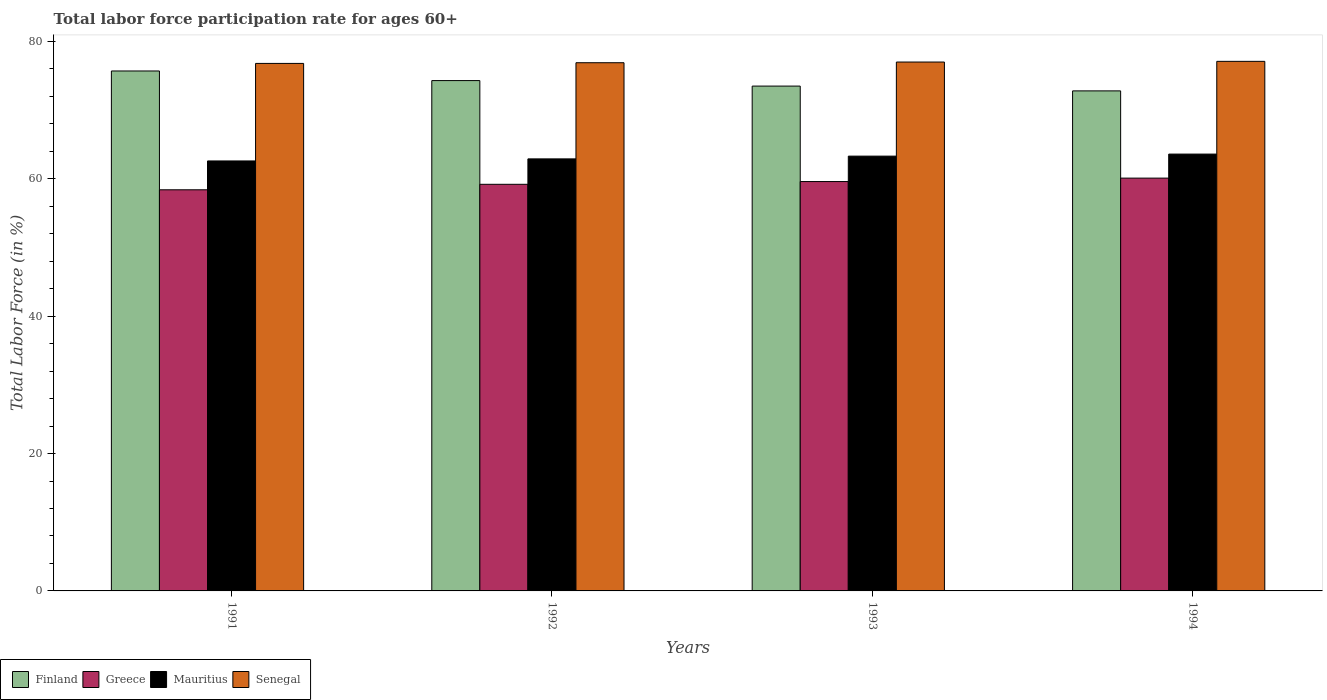How many groups of bars are there?
Give a very brief answer. 4. Are the number of bars per tick equal to the number of legend labels?
Your response must be concise. Yes. Are the number of bars on each tick of the X-axis equal?
Your answer should be compact. Yes. In how many cases, is the number of bars for a given year not equal to the number of legend labels?
Your answer should be compact. 0. What is the labor force participation rate in Greece in 1991?
Make the answer very short. 58.4. Across all years, what is the maximum labor force participation rate in Senegal?
Provide a succinct answer. 77.1. Across all years, what is the minimum labor force participation rate in Greece?
Provide a succinct answer. 58.4. In which year was the labor force participation rate in Greece maximum?
Make the answer very short. 1994. In which year was the labor force participation rate in Senegal minimum?
Your response must be concise. 1991. What is the total labor force participation rate in Finland in the graph?
Your answer should be compact. 296.3. What is the difference between the labor force participation rate in Finland in 1991 and that in 1994?
Offer a terse response. 2.9. What is the difference between the labor force participation rate in Finland in 1992 and the labor force participation rate in Mauritius in 1994?
Provide a succinct answer. 10.7. What is the average labor force participation rate in Mauritius per year?
Offer a very short reply. 63.1. In the year 1994, what is the difference between the labor force participation rate in Greece and labor force participation rate in Mauritius?
Ensure brevity in your answer.  -3.5. In how many years, is the labor force participation rate in Senegal greater than 12 %?
Provide a short and direct response. 4. What is the ratio of the labor force participation rate in Greece in 1991 to that in 1994?
Ensure brevity in your answer.  0.97. What is the difference between the highest and the lowest labor force participation rate in Greece?
Your answer should be very brief. 1.7. Is the sum of the labor force participation rate in Mauritius in 1992 and 1994 greater than the maximum labor force participation rate in Greece across all years?
Your answer should be compact. Yes. What does the 2nd bar from the left in 1991 represents?
Provide a short and direct response. Greece. What does the 2nd bar from the right in 1993 represents?
Give a very brief answer. Mauritius. How many bars are there?
Provide a succinct answer. 16. Are all the bars in the graph horizontal?
Ensure brevity in your answer.  No. What is the difference between two consecutive major ticks on the Y-axis?
Your answer should be compact. 20. Where does the legend appear in the graph?
Your answer should be very brief. Bottom left. How many legend labels are there?
Offer a terse response. 4. How are the legend labels stacked?
Ensure brevity in your answer.  Horizontal. What is the title of the graph?
Offer a very short reply. Total labor force participation rate for ages 60+. Does "Micronesia" appear as one of the legend labels in the graph?
Your answer should be compact. No. What is the Total Labor Force (in %) of Finland in 1991?
Offer a very short reply. 75.7. What is the Total Labor Force (in %) of Greece in 1991?
Your answer should be compact. 58.4. What is the Total Labor Force (in %) in Mauritius in 1991?
Offer a terse response. 62.6. What is the Total Labor Force (in %) of Senegal in 1991?
Keep it short and to the point. 76.8. What is the Total Labor Force (in %) in Finland in 1992?
Provide a succinct answer. 74.3. What is the Total Labor Force (in %) in Greece in 1992?
Ensure brevity in your answer.  59.2. What is the Total Labor Force (in %) in Mauritius in 1992?
Offer a very short reply. 62.9. What is the Total Labor Force (in %) of Senegal in 1992?
Offer a terse response. 76.9. What is the Total Labor Force (in %) in Finland in 1993?
Ensure brevity in your answer.  73.5. What is the Total Labor Force (in %) of Greece in 1993?
Provide a short and direct response. 59.6. What is the Total Labor Force (in %) in Mauritius in 1993?
Offer a terse response. 63.3. What is the Total Labor Force (in %) of Senegal in 1993?
Provide a succinct answer. 77. What is the Total Labor Force (in %) in Finland in 1994?
Offer a terse response. 72.8. What is the Total Labor Force (in %) in Greece in 1994?
Your response must be concise. 60.1. What is the Total Labor Force (in %) in Mauritius in 1994?
Offer a terse response. 63.6. What is the Total Labor Force (in %) in Senegal in 1994?
Your answer should be very brief. 77.1. Across all years, what is the maximum Total Labor Force (in %) in Finland?
Your answer should be very brief. 75.7. Across all years, what is the maximum Total Labor Force (in %) of Greece?
Your answer should be compact. 60.1. Across all years, what is the maximum Total Labor Force (in %) of Mauritius?
Provide a short and direct response. 63.6. Across all years, what is the maximum Total Labor Force (in %) in Senegal?
Your answer should be compact. 77.1. Across all years, what is the minimum Total Labor Force (in %) of Finland?
Keep it short and to the point. 72.8. Across all years, what is the minimum Total Labor Force (in %) in Greece?
Offer a very short reply. 58.4. Across all years, what is the minimum Total Labor Force (in %) of Mauritius?
Offer a very short reply. 62.6. Across all years, what is the minimum Total Labor Force (in %) in Senegal?
Make the answer very short. 76.8. What is the total Total Labor Force (in %) of Finland in the graph?
Offer a very short reply. 296.3. What is the total Total Labor Force (in %) in Greece in the graph?
Your answer should be compact. 237.3. What is the total Total Labor Force (in %) of Mauritius in the graph?
Your answer should be compact. 252.4. What is the total Total Labor Force (in %) in Senegal in the graph?
Give a very brief answer. 307.8. What is the difference between the Total Labor Force (in %) in Greece in 1991 and that in 1992?
Offer a terse response. -0.8. What is the difference between the Total Labor Force (in %) of Mauritius in 1991 and that in 1993?
Your response must be concise. -0.7. What is the difference between the Total Labor Force (in %) of Finland in 1991 and that in 1994?
Your answer should be very brief. 2.9. What is the difference between the Total Labor Force (in %) of Finland in 1992 and that in 1993?
Provide a succinct answer. 0.8. What is the difference between the Total Labor Force (in %) of Mauritius in 1992 and that in 1993?
Offer a very short reply. -0.4. What is the difference between the Total Labor Force (in %) of Senegal in 1992 and that in 1993?
Give a very brief answer. -0.1. What is the difference between the Total Labor Force (in %) of Greece in 1992 and that in 1994?
Give a very brief answer. -0.9. What is the difference between the Total Labor Force (in %) in Senegal in 1992 and that in 1994?
Offer a very short reply. -0.2. What is the difference between the Total Labor Force (in %) of Finland in 1993 and that in 1994?
Offer a very short reply. 0.7. What is the difference between the Total Labor Force (in %) in Greece in 1993 and that in 1994?
Your response must be concise. -0.5. What is the difference between the Total Labor Force (in %) of Senegal in 1993 and that in 1994?
Give a very brief answer. -0.1. What is the difference between the Total Labor Force (in %) in Finland in 1991 and the Total Labor Force (in %) in Mauritius in 1992?
Make the answer very short. 12.8. What is the difference between the Total Labor Force (in %) of Finland in 1991 and the Total Labor Force (in %) of Senegal in 1992?
Keep it short and to the point. -1.2. What is the difference between the Total Labor Force (in %) in Greece in 1991 and the Total Labor Force (in %) in Senegal in 1992?
Your answer should be compact. -18.5. What is the difference between the Total Labor Force (in %) in Mauritius in 1991 and the Total Labor Force (in %) in Senegal in 1992?
Give a very brief answer. -14.3. What is the difference between the Total Labor Force (in %) of Finland in 1991 and the Total Labor Force (in %) of Greece in 1993?
Your answer should be very brief. 16.1. What is the difference between the Total Labor Force (in %) of Finland in 1991 and the Total Labor Force (in %) of Mauritius in 1993?
Offer a very short reply. 12.4. What is the difference between the Total Labor Force (in %) in Greece in 1991 and the Total Labor Force (in %) in Mauritius in 1993?
Your answer should be compact. -4.9. What is the difference between the Total Labor Force (in %) in Greece in 1991 and the Total Labor Force (in %) in Senegal in 1993?
Give a very brief answer. -18.6. What is the difference between the Total Labor Force (in %) in Mauritius in 1991 and the Total Labor Force (in %) in Senegal in 1993?
Your answer should be compact. -14.4. What is the difference between the Total Labor Force (in %) of Finland in 1991 and the Total Labor Force (in %) of Mauritius in 1994?
Your answer should be very brief. 12.1. What is the difference between the Total Labor Force (in %) of Finland in 1991 and the Total Labor Force (in %) of Senegal in 1994?
Your answer should be compact. -1.4. What is the difference between the Total Labor Force (in %) of Greece in 1991 and the Total Labor Force (in %) of Mauritius in 1994?
Ensure brevity in your answer.  -5.2. What is the difference between the Total Labor Force (in %) in Greece in 1991 and the Total Labor Force (in %) in Senegal in 1994?
Your response must be concise. -18.7. What is the difference between the Total Labor Force (in %) in Mauritius in 1991 and the Total Labor Force (in %) in Senegal in 1994?
Your answer should be compact. -14.5. What is the difference between the Total Labor Force (in %) in Finland in 1992 and the Total Labor Force (in %) in Greece in 1993?
Give a very brief answer. 14.7. What is the difference between the Total Labor Force (in %) of Finland in 1992 and the Total Labor Force (in %) of Senegal in 1993?
Your answer should be very brief. -2.7. What is the difference between the Total Labor Force (in %) in Greece in 1992 and the Total Labor Force (in %) in Senegal in 1993?
Make the answer very short. -17.8. What is the difference between the Total Labor Force (in %) in Mauritius in 1992 and the Total Labor Force (in %) in Senegal in 1993?
Your response must be concise. -14.1. What is the difference between the Total Labor Force (in %) in Finland in 1992 and the Total Labor Force (in %) in Greece in 1994?
Ensure brevity in your answer.  14.2. What is the difference between the Total Labor Force (in %) in Finland in 1992 and the Total Labor Force (in %) in Mauritius in 1994?
Ensure brevity in your answer.  10.7. What is the difference between the Total Labor Force (in %) of Finland in 1992 and the Total Labor Force (in %) of Senegal in 1994?
Give a very brief answer. -2.8. What is the difference between the Total Labor Force (in %) in Greece in 1992 and the Total Labor Force (in %) in Mauritius in 1994?
Provide a succinct answer. -4.4. What is the difference between the Total Labor Force (in %) of Greece in 1992 and the Total Labor Force (in %) of Senegal in 1994?
Your answer should be very brief. -17.9. What is the difference between the Total Labor Force (in %) in Mauritius in 1992 and the Total Labor Force (in %) in Senegal in 1994?
Your answer should be compact. -14.2. What is the difference between the Total Labor Force (in %) in Finland in 1993 and the Total Labor Force (in %) in Greece in 1994?
Provide a short and direct response. 13.4. What is the difference between the Total Labor Force (in %) in Greece in 1993 and the Total Labor Force (in %) in Senegal in 1994?
Make the answer very short. -17.5. What is the difference between the Total Labor Force (in %) in Mauritius in 1993 and the Total Labor Force (in %) in Senegal in 1994?
Keep it short and to the point. -13.8. What is the average Total Labor Force (in %) of Finland per year?
Offer a very short reply. 74.08. What is the average Total Labor Force (in %) of Greece per year?
Provide a short and direct response. 59.33. What is the average Total Labor Force (in %) of Mauritius per year?
Provide a succinct answer. 63.1. What is the average Total Labor Force (in %) in Senegal per year?
Provide a succinct answer. 76.95. In the year 1991, what is the difference between the Total Labor Force (in %) in Finland and Total Labor Force (in %) in Greece?
Ensure brevity in your answer.  17.3. In the year 1991, what is the difference between the Total Labor Force (in %) in Finland and Total Labor Force (in %) in Mauritius?
Ensure brevity in your answer.  13.1. In the year 1991, what is the difference between the Total Labor Force (in %) of Finland and Total Labor Force (in %) of Senegal?
Your answer should be very brief. -1.1. In the year 1991, what is the difference between the Total Labor Force (in %) in Greece and Total Labor Force (in %) in Senegal?
Provide a succinct answer. -18.4. In the year 1991, what is the difference between the Total Labor Force (in %) of Mauritius and Total Labor Force (in %) of Senegal?
Make the answer very short. -14.2. In the year 1992, what is the difference between the Total Labor Force (in %) in Finland and Total Labor Force (in %) in Greece?
Make the answer very short. 15.1. In the year 1992, what is the difference between the Total Labor Force (in %) in Finland and Total Labor Force (in %) in Mauritius?
Your answer should be compact. 11.4. In the year 1992, what is the difference between the Total Labor Force (in %) in Finland and Total Labor Force (in %) in Senegal?
Give a very brief answer. -2.6. In the year 1992, what is the difference between the Total Labor Force (in %) in Greece and Total Labor Force (in %) in Mauritius?
Provide a short and direct response. -3.7. In the year 1992, what is the difference between the Total Labor Force (in %) in Greece and Total Labor Force (in %) in Senegal?
Give a very brief answer. -17.7. In the year 1992, what is the difference between the Total Labor Force (in %) of Mauritius and Total Labor Force (in %) of Senegal?
Your response must be concise. -14. In the year 1993, what is the difference between the Total Labor Force (in %) of Finland and Total Labor Force (in %) of Senegal?
Your response must be concise. -3.5. In the year 1993, what is the difference between the Total Labor Force (in %) in Greece and Total Labor Force (in %) in Mauritius?
Give a very brief answer. -3.7. In the year 1993, what is the difference between the Total Labor Force (in %) in Greece and Total Labor Force (in %) in Senegal?
Your answer should be compact. -17.4. In the year 1993, what is the difference between the Total Labor Force (in %) in Mauritius and Total Labor Force (in %) in Senegal?
Ensure brevity in your answer.  -13.7. In the year 1994, what is the difference between the Total Labor Force (in %) in Finland and Total Labor Force (in %) in Mauritius?
Your answer should be compact. 9.2. In the year 1994, what is the difference between the Total Labor Force (in %) of Greece and Total Labor Force (in %) of Senegal?
Ensure brevity in your answer.  -17. What is the ratio of the Total Labor Force (in %) of Finland in 1991 to that in 1992?
Your response must be concise. 1.02. What is the ratio of the Total Labor Force (in %) of Greece in 1991 to that in 1992?
Provide a succinct answer. 0.99. What is the ratio of the Total Labor Force (in %) in Finland in 1991 to that in 1993?
Your answer should be compact. 1.03. What is the ratio of the Total Labor Force (in %) in Greece in 1991 to that in 1993?
Your answer should be compact. 0.98. What is the ratio of the Total Labor Force (in %) of Mauritius in 1991 to that in 1993?
Ensure brevity in your answer.  0.99. What is the ratio of the Total Labor Force (in %) in Finland in 1991 to that in 1994?
Provide a succinct answer. 1.04. What is the ratio of the Total Labor Force (in %) in Greece in 1991 to that in 1994?
Ensure brevity in your answer.  0.97. What is the ratio of the Total Labor Force (in %) in Mauritius in 1991 to that in 1994?
Provide a succinct answer. 0.98. What is the ratio of the Total Labor Force (in %) in Senegal in 1991 to that in 1994?
Provide a short and direct response. 1. What is the ratio of the Total Labor Force (in %) in Finland in 1992 to that in 1993?
Give a very brief answer. 1.01. What is the ratio of the Total Labor Force (in %) of Greece in 1992 to that in 1993?
Ensure brevity in your answer.  0.99. What is the ratio of the Total Labor Force (in %) in Mauritius in 1992 to that in 1993?
Your answer should be very brief. 0.99. What is the ratio of the Total Labor Force (in %) of Senegal in 1992 to that in 1993?
Your answer should be very brief. 1. What is the ratio of the Total Labor Force (in %) of Finland in 1992 to that in 1994?
Your answer should be very brief. 1.02. What is the ratio of the Total Labor Force (in %) in Finland in 1993 to that in 1994?
Ensure brevity in your answer.  1.01. What is the ratio of the Total Labor Force (in %) in Greece in 1993 to that in 1994?
Give a very brief answer. 0.99. What is the ratio of the Total Labor Force (in %) in Mauritius in 1993 to that in 1994?
Make the answer very short. 1. What is the difference between the highest and the second highest Total Labor Force (in %) of Finland?
Keep it short and to the point. 1.4. What is the difference between the highest and the second highest Total Labor Force (in %) in Greece?
Your answer should be compact. 0.5. What is the difference between the highest and the second highest Total Labor Force (in %) of Mauritius?
Offer a very short reply. 0.3. What is the difference between the highest and the second highest Total Labor Force (in %) in Senegal?
Provide a succinct answer. 0.1. What is the difference between the highest and the lowest Total Labor Force (in %) of Greece?
Your answer should be compact. 1.7. What is the difference between the highest and the lowest Total Labor Force (in %) of Mauritius?
Your answer should be compact. 1. What is the difference between the highest and the lowest Total Labor Force (in %) in Senegal?
Your response must be concise. 0.3. 